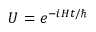<formula> <loc_0><loc_0><loc_500><loc_500>U = e ^ { - i H t / }</formula> 